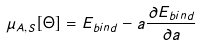<formula> <loc_0><loc_0><loc_500><loc_500>\mu _ { A , S } [ \Theta ] = E _ { b i n d } - a \frac { \partial E _ { b i n d } } { \partial a }</formula> 